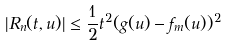Convert formula to latex. <formula><loc_0><loc_0><loc_500><loc_500>| R _ { n } ( t , u ) | \leq \frac { 1 } { 2 } t ^ { 2 } ( g ( u ) - f _ { m } ( u ) ) ^ { 2 }</formula> 